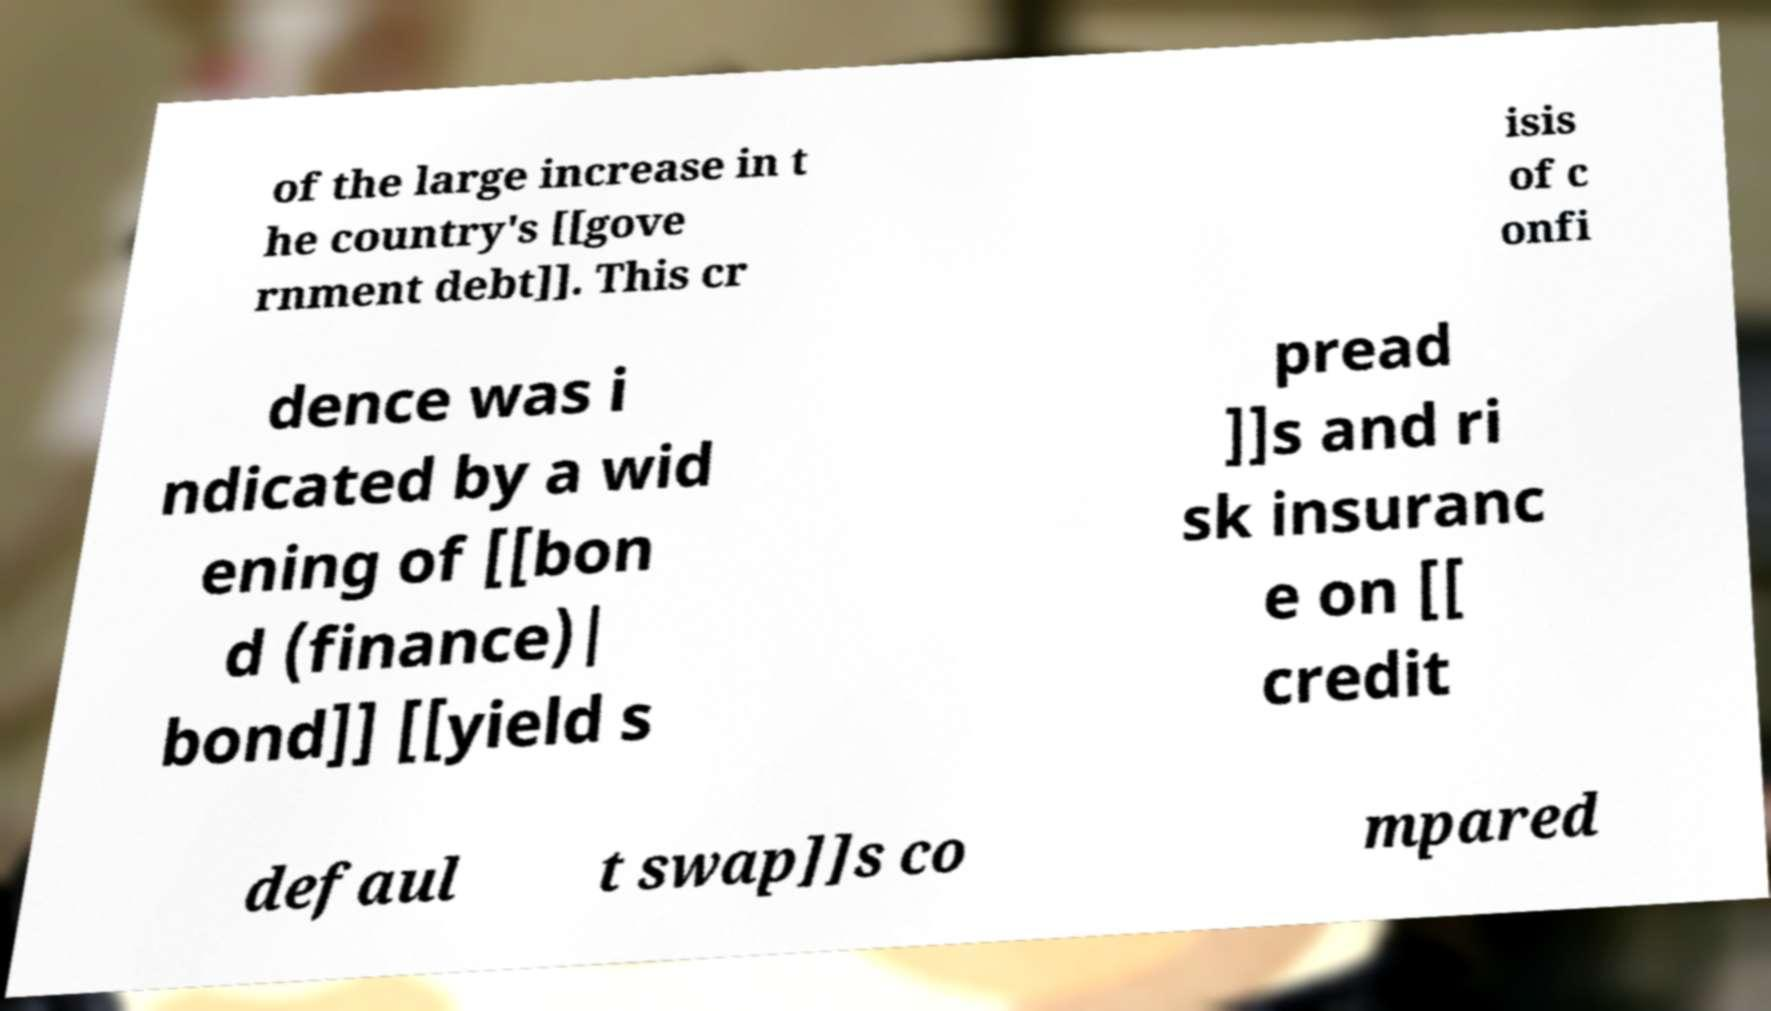There's text embedded in this image that I need extracted. Can you transcribe it verbatim? of the large increase in t he country's [[gove rnment debt]]. This cr isis of c onfi dence was i ndicated by a wid ening of [[bon d (finance)| bond]] [[yield s pread ]]s and ri sk insuranc e on [[ credit defaul t swap]]s co mpared 